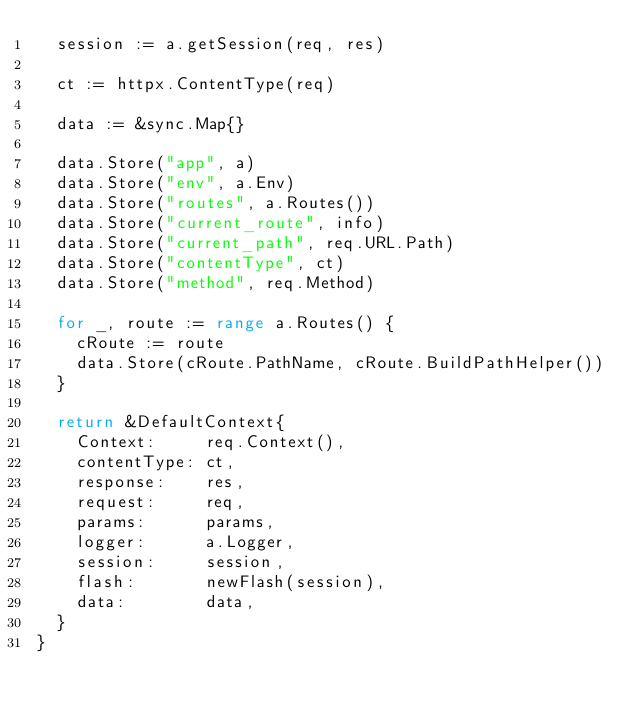Convert code to text. <code><loc_0><loc_0><loc_500><loc_500><_Go_>	session := a.getSession(req, res)

	ct := httpx.ContentType(req)

	data := &sync.Map{}

	data.Store("app", a)
	data.Store("env", a.Env)
	data.Store("routes", a.Routes())
	data.Store("current_route", info)
	data.Store("current_path", req.URL.Path)
	data.Store("contentType", ct)
	data.Store("method", req.Method)

	for _, route := range a.Routes() {
		cRoute := route
		data.Store(cRoute.PathName, cRoute.BuildPathHelper())
	}

	return &DefaultContext{
		Context:     req.Context(),
		contentType: ct,
		response:    res,
		request:     req,
		params:      params,
		logger:      a.Logger,
		session:     session,
		flash:       newFlash(session),
		data:        data,
	}
}
</code> 